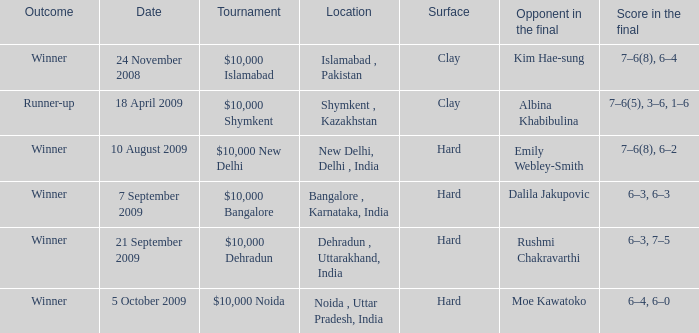What type of material constitutes the surface in noida, uttar pradesh, india? Hard. 